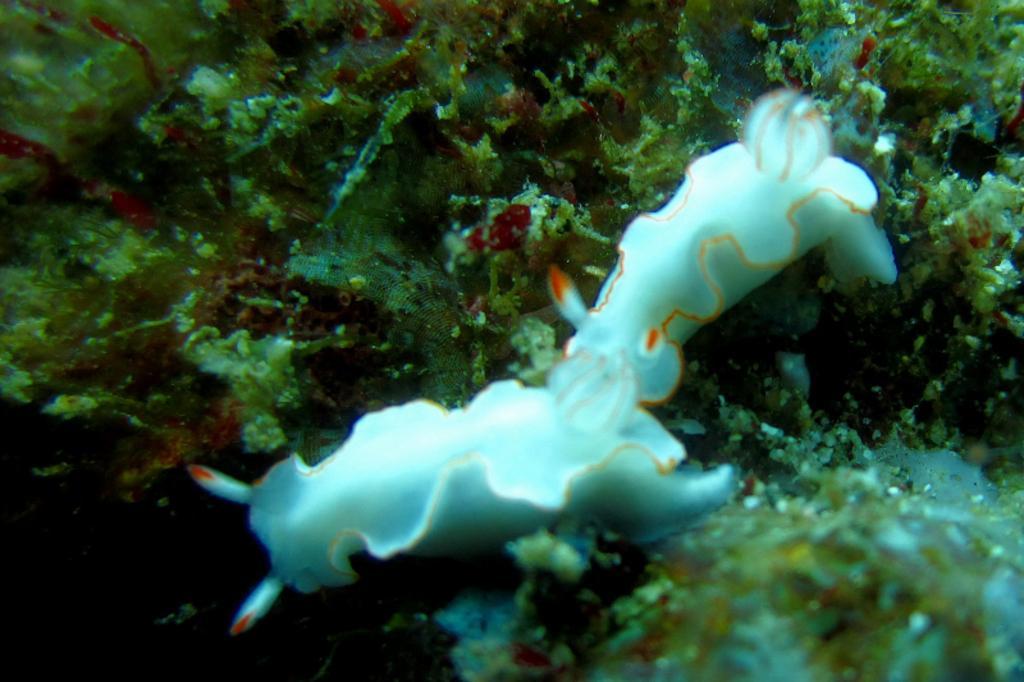In one or two sentences, can you explain what this image depicts? The picture consists of and water animal and algae. This is a picture taken in water. 